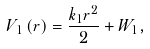Convert formula to latex. <formula><loc_0><loc_0><loc_500><loc_500>V _ { 1 } \left ( r \right ) = \frac { k _ { 1 } r ^ { 2 } } { 2 } + W _ { 1 } ,</formula> 